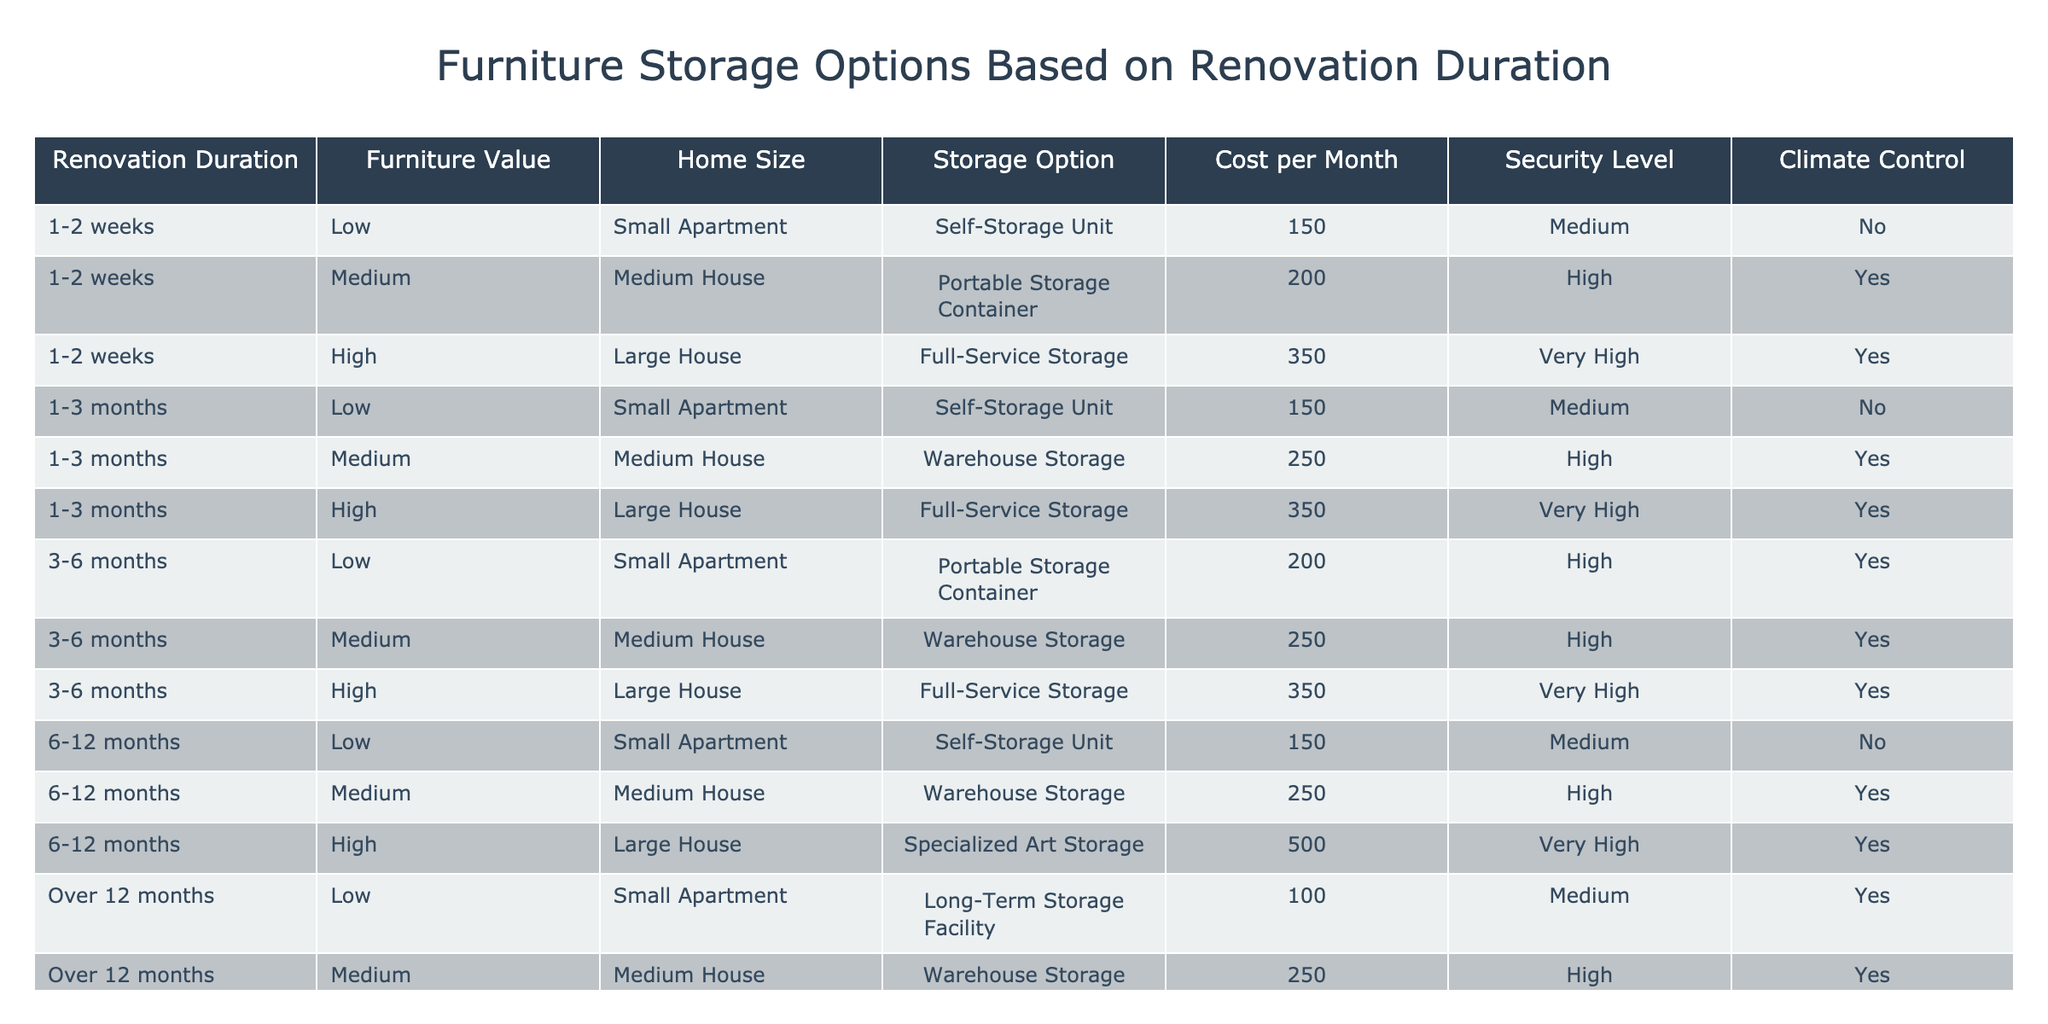What is the cost per month for a self-storage unit for a renovation duration of 1-2 weeks? According to the table, for a renovation duration of 1-2 weeks with low furniture value in a small apartment, the cost per month for a self-storage unit is stated as 150.
Answer: 150 Which storage option has the highest monthly cost for a renovation duration of 6-12 months? The table shows that for a renovation duration of 6-12 months, the specialized art storage has the highest monthly cost, which is 500.
Answer: 500 Is climate control available for portable storage containers for any renovation duration? In the table, climate control is marked as 'Yes' for portable storage containers only under the duration of 3-6 months. Therefore, climate control is not available for other durations.
Answer: No What is the average cost per month for medium-sized houses across all renovation durations? From the table for medium houses, the costs are: 200 (1-2 weeks), 250 (1-3 months), 250 (3-6 months), 250 (6-12 months), and 250 (over 12 months). The sum is 200 + 250 + 250 + 250 + 250 = 1200. There are 5 entries, so the average is 1200/5 = 240.
Answer: 240 How many storage options provide high security for low-value furniture during renovations lasting over 12 months? Reviewing the table, for over 12 months with low-value furniture, the options listed are long-term storage facility (medium security) and warehouse storage (high security). Therefore, only the warehouse storage option provides high security.
Answer: 1 What is the difference in monthly cost between the highest and lowest options for furniture storage for medium houses? The highest cost for medium houses is 250 for warehouse storage (for 1-3 months, 3-6 months, and over 12 months) and the lowest is 200 for portable storage containers (1-2 weeks). The difference is 250 - 200 = 50.
Answer: 50 Are all furniture storage options for large houses climate controlled? The table indicates that for large houses, full-service storage and specialized art storage have climate control, whereas there is no climate control for some options (like portable storage). Thus, not all options are climate controlled.
Answer: No Which storage option is the least expensive for low-value furniture in a small apartment? From the table, the self-storage unit has the least expensive cost per month of 150 for low-value furniture in a small apartment across different renovation durations.
Answer: 150 What is the total monthly cost for all storage options for high-value furniture? The costs for high-value furniture from the table are: 350 (1-2 weeks), 350 (1-3 months), 350 (3-6 months), 500 (6-12 months), and 500 (over 12 months). Summing these gives 350 + 350 + 350 + 500 + 500 = 2050.
Answer: 2050 